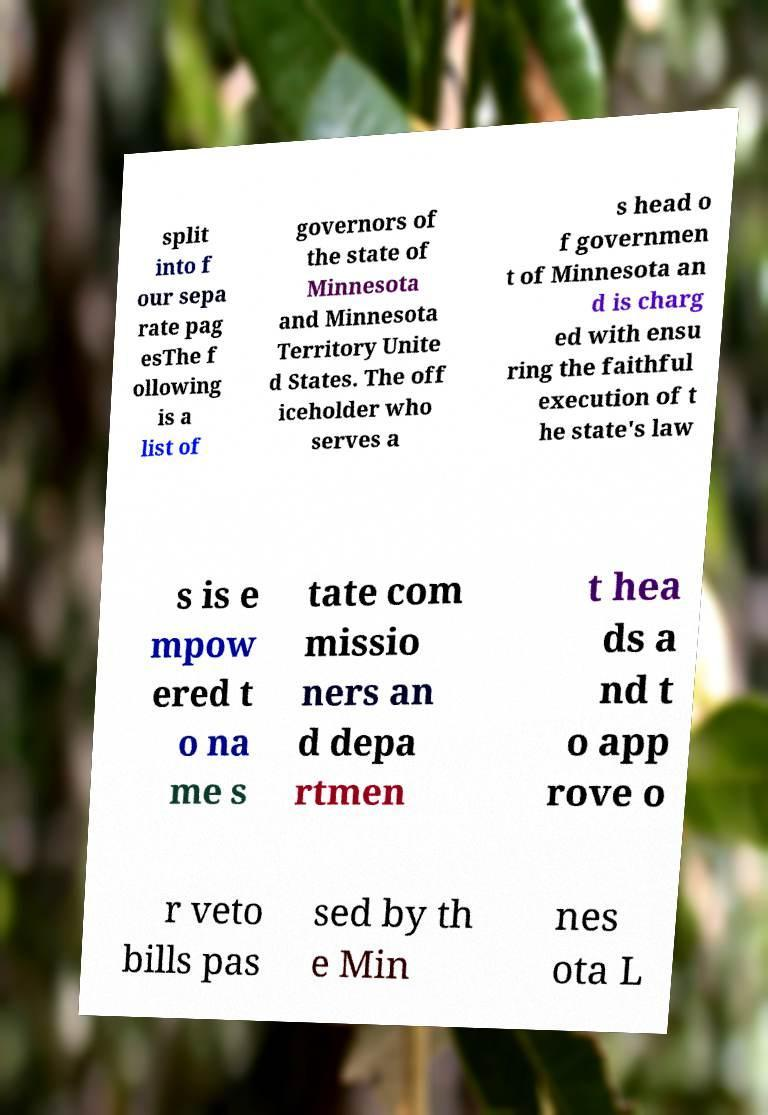For documentation purposes, I need the text within this image transcribed. Could you provide that? split into f our sepa rate pag esThe f ollowing is a list of governors of the state of Minnesota and Minnesota Territory Unite d States. The off iceholder who serves a s head o f governmen t of Minnesota an d is charg ed with ensu ring the faithful execution of t he state's law s is e mpow ered t o na me s tate com missio ners an d depa rtmen t hea ds a nd t o app rove o r veto bills pas sed by th e Min nes ota L 